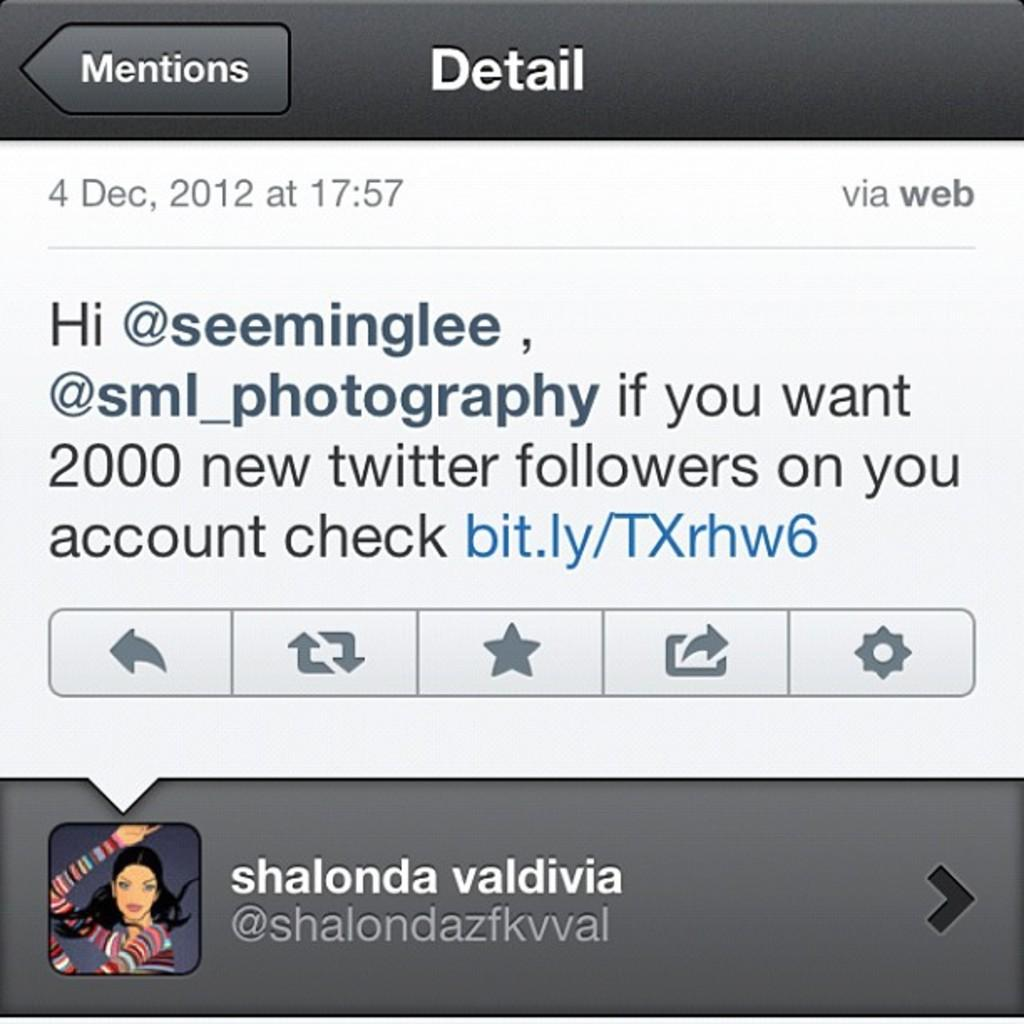What type of image is displayed in the screenshot? The image contains a screenshot. What can be seen on the screenshot? There is text and symbols on the screenshot. Is there any personalization on the screenshot? Yes, there is a profile photo on the screenshot. Can you tell me how many hospitals are visible in the screenshot? There are no hospitals visible in the screenshot; it contains text, symbols, and a profile photo. Is there a slope in the screenshot? There is no slope present in the screenshot. 